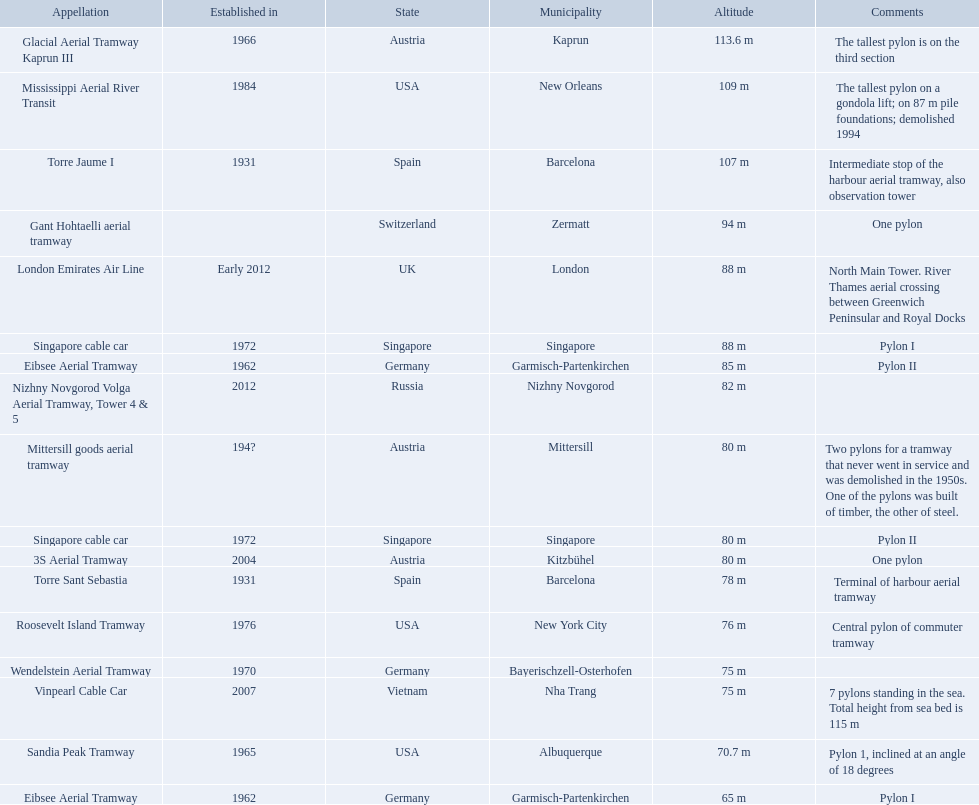Which aerial lifts are over 100 meters tall? Glacial Aerial Tramway Kaprun III, Mississippi Aerial River Transit, Torre Jaume I. Which of those was built last? Mississippi Aerial River Transit. And what is its total height? 109 m. 